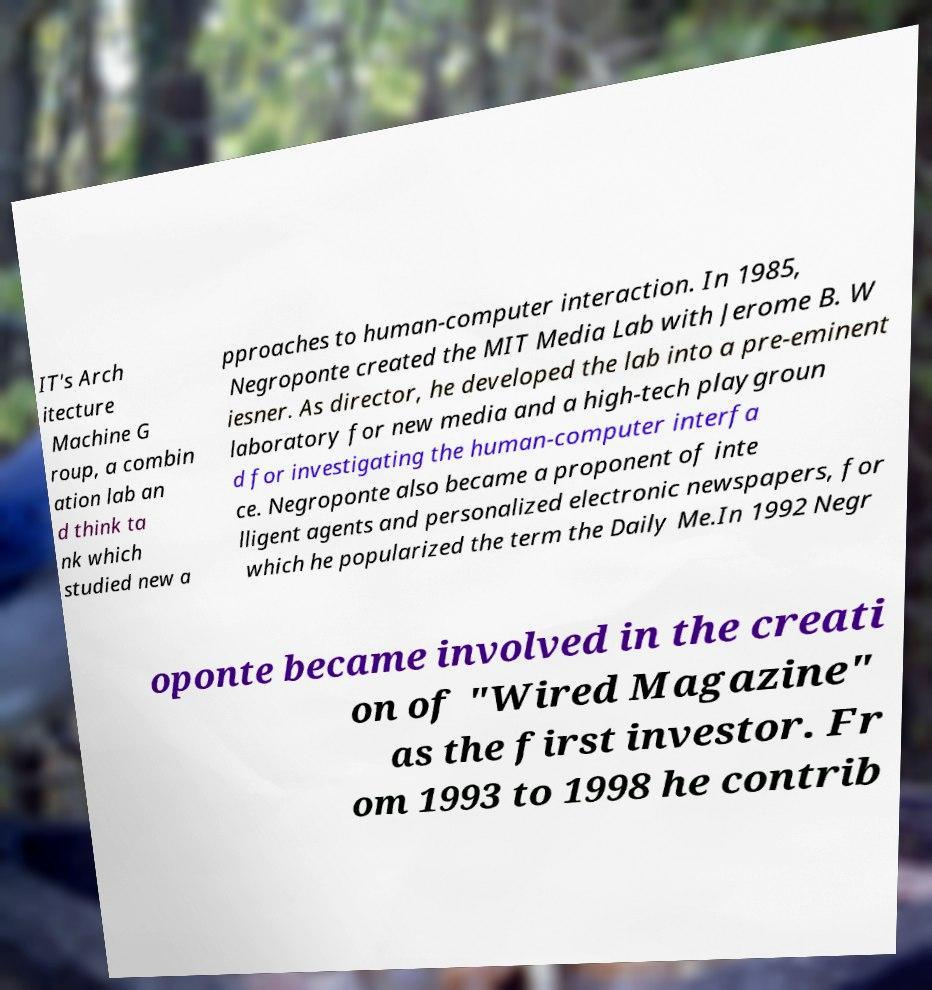Can you read and provide the text displayed in the image?This photo seems to have some interesting text. Can you extract and type it out for me? IT's Arch itecture Machine G roup, a combin ation lab an d think ta nk which studied new a pproaches to human-computer interaction. In 1985, Negroponte created the MIT Media Lab with Jerome B. W iesner. As director, he developed the lab into a pre-eminent laboratory for new media and a high-tech playgroun d for investigating the human-computer interfa ce. Negroponte also became a proponent of inte lligent agents and personalized electronic newspapers, for which he popularized the term the Daily Me.In 1992 Negr oponte became involved in the creati on of "Wired Magazine" as the first investor. Fr om 1993 to 1998 he contrib 